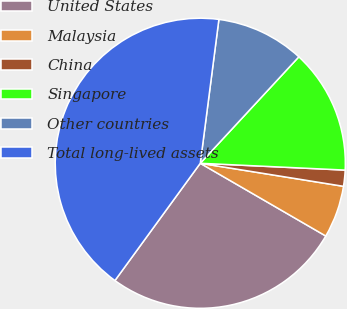<chart> <loc_0><loc_0><loc_500><loc_500><pie_chart><fcel>United States<fcel>Malaysia<fcel>China<fcel>Singapore<fcel>Other countries<fcel>Total long-lived assets<nl><fcel>26.65%<fcel>5.82%<fcel>1.79%<fcel>13.86%<fcel>9.84%<fcel>42.03%<nl></chart> 